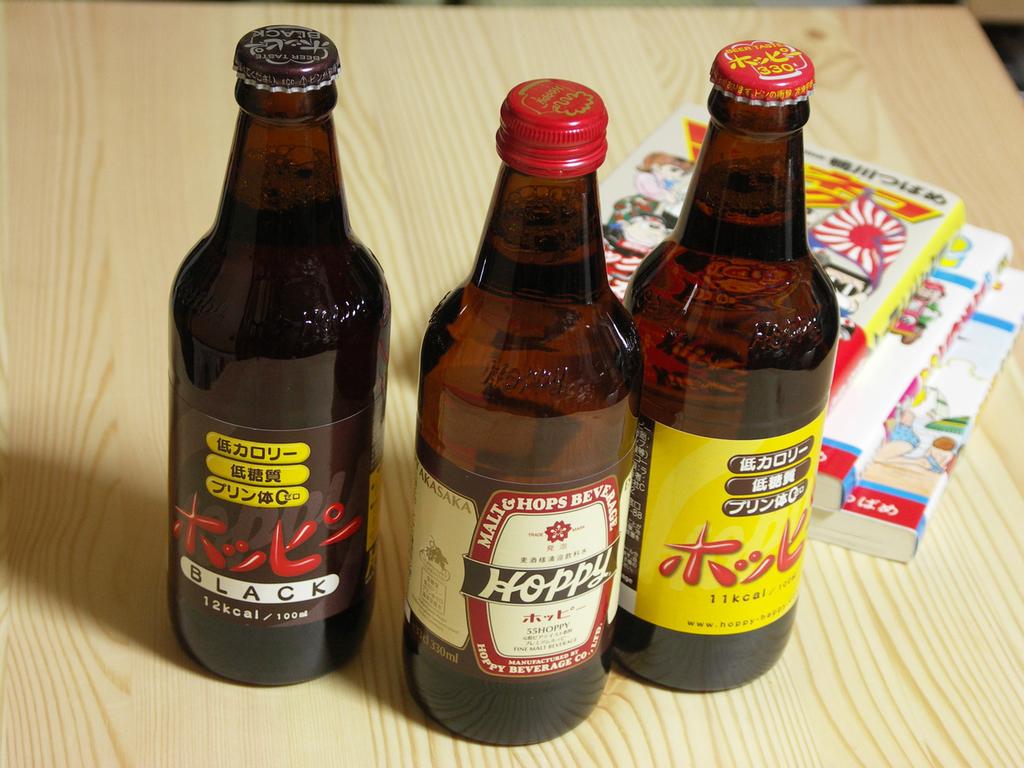What color is cited on the left most beer bottle?
Your response must be concise. Black. What does the bottle in the center say is its name in english?
Offer a terse response. Hoppy. 